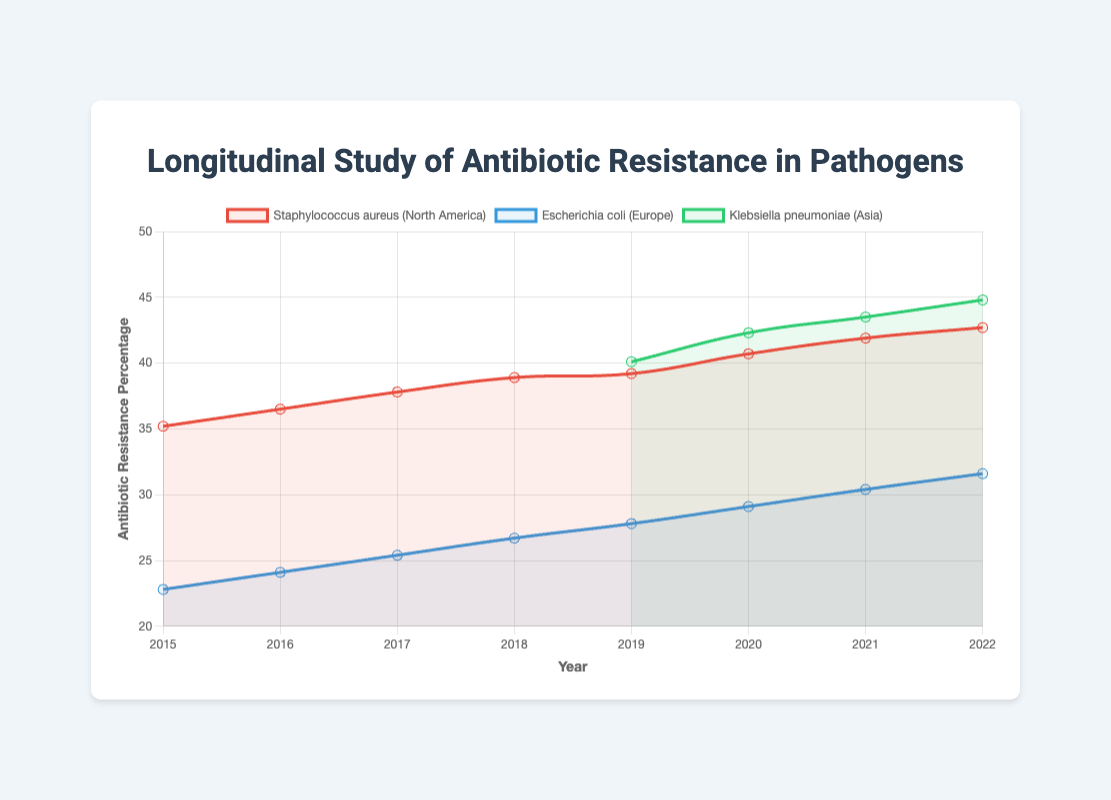Which pathogen had the highest antibiotic resistance percentage in 2022? In 2022, Klebsiella pneumoniae had the highest antibiotic resistance percentage at 44.8%, surpassing Staphylococcus aureus (42.7%) and Escherichia coli (31.6%)
Answer: Klebsiella pneumoniae How did the antibiotic resistance percentage of Escherichia coli change from 2015 to 2022? The percentage in 2015 was 22.8%, and by 2022, it increased to 31.6%. Calculate the increase: 31.6% - 22.8% = 8.8%
Answer: Increased by 8.8% In 2019, what was the difference in antibiotic resistance percentage between Klebsiella pneumoniae and Escherichia coli? In 2019, Klebsiella pneumoniae had 40.1% resistance, and Escherichia coli had 27.8%. The difference is 40.1% - 27.8% = 12.3%
Answer: 12.3% Which pathogen in the dataset showed a consistent increase in antibiotic resistance percentage over the years? Klebsiella pneumoniae showed a consistent increase each year from 2019 (40.1%) to 2022 (44.8%), and Staphylococcus aureus also showed an increase from 2015 (35.2%) to 2022 (42.7%)
Answer: Klebsiella pneumoniae, Staphylococcus aureus How does the antibiotic resistance of Escherichia coli in 2022 compare to its resistance in 2015? In 2022, the resistance was 31.6%, compared to 22.8% in 2015. It increased by 31.6% - 22.8% = 8.8%. Visually, the line chart shows an upward trend from 2015 to 2022
Answer: It increased by 8.8% What was the average antibiotic resistance percentage of Staphylococcus aureus in North America from 2015 to 2022? The resistance percentages for Staphylococcus aureus were 35.2 (2015), 36.5 (2016), 37.8 (2017), 38.9 (2018), 39.2 (2019), 40.7 (2020), 41.9 (2021), and 42.7 (2022). Average = (35.2 + 36.5 + 37.8 + 38.9 + 39.2 + 40.7 + 41.9 + 42.7) / 8 = 39.1%
Answer: 39.1% Between 2015 and 2022, which pathogen had the lowest antibiotic resistance percentage at any point, and what was that percentage? The lowest resistance percentage was for Escherichia coli in 2015 with 22.8%. Throughout the dataset, no other pathogen had a lower percentage than this
Answer: Escherichia coli, 22.8% From 2019 to 2022, which year saw the largest increase in antibiotic resistance percentage for Klebsiella pneumoniae? The changes for Klebsiella pneumoniae are: 2019 to 2020: 42.3% - 40.1% = 2.2%, 2020 to 2021: 43.5% - 42.3% = 1.2%, and 2021 to 2022: 44.8% - 43.5% = 1.3%. The largest increase was between 2019 and 2020 (2.2%)
Answer: 2019 to 2020 Compare the trend lines of Staphylococcus aureus and Escherichia coli from 2015 to 2022. Which pathogen had a more consistent increase in antibiotic resistance? Staphylococcus aureus exhibited a consistent increase each year whereas Escherichia coli had increases but also periods of smaller increments. The visual clarity of the line representing Staphylococcus aureus shows a more uniform upward slope compared to Escherichia coli
Answer: Staphylococcus aureus 